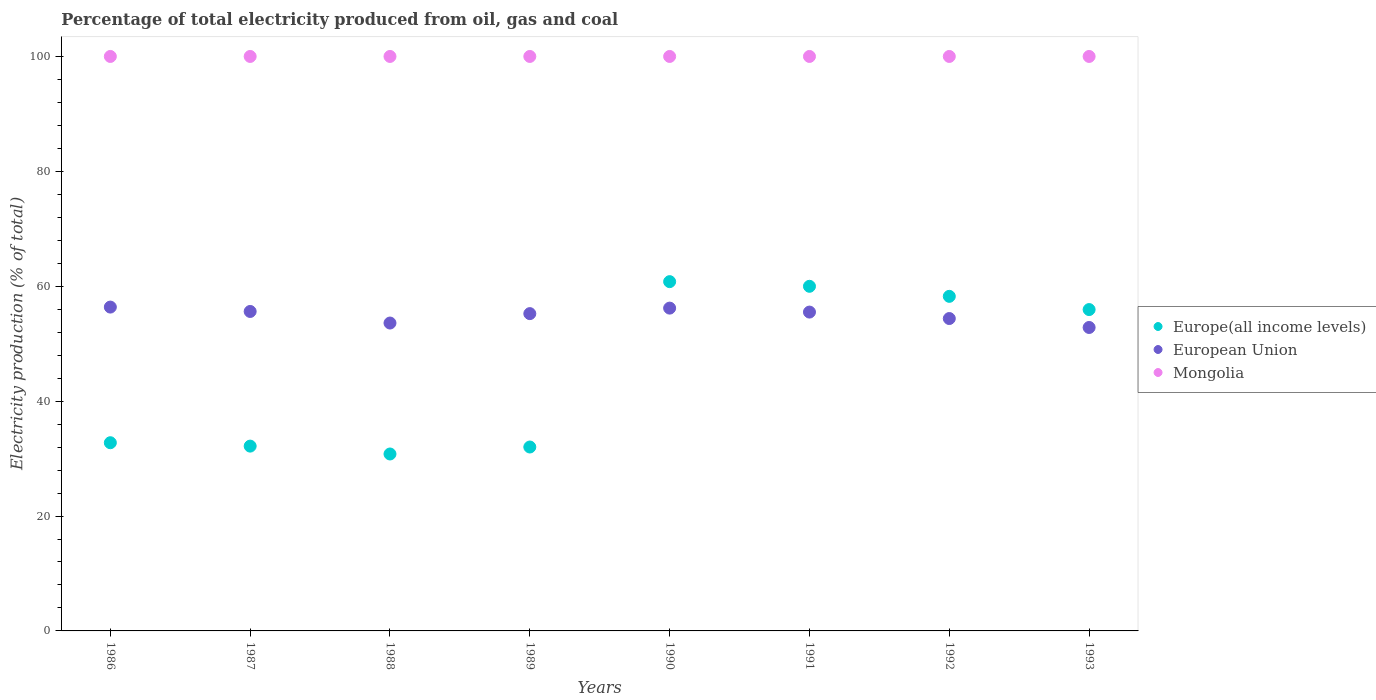What is the electricity production in in European Union in 1992?
Keep it short and to the point. 54.38. Across all years, what is the maximum electricity production in in Europe(all income levels)?
Ensure brevity in your answer.  60.8. Across all years, what is the minimum electricity production in in European Union?
Your response must be concise. 52.82. In which year was the electricity production in in Mongolia maximum?
Offer a very short reply. 1986. In which year was the electricity production in in Mongolia minimum?
Provide a succinct answer. 1986. What is the total electricity production in in Europe(all income levels) in the graph?
Your response must be concise. 362.71. What is the difference between the electricity production in in Mongolia in 1993 and the electricity production in in European Union in 1989?
Make the answer very short. 44.77. In the year 1989, what is the difference between the electricity production in in Mongolia and electricity production in in Europe(all income levels)?
Your response must be concise. 67.99. In how many years, is the electricity production in in Mongolia greater than 60 %?
Your answer should be very brief. 8. What is the ratio of the electricity production in in European Union in 1987 to that in 1992?
Give a very brief answer. 1.02. What is the difference between the highest and the second highest electricity production in in European Union?
Provide a short and direct response. 0.18. What is the difference between the highest and the lowest electricity production in in Europe(all income levels)?
Ensure brevity in your answer.  30. In how many years, is the electricity production in in Europe(all income levels) greater than the average electricity production in in Europe(all income levels) taken over all years?
Your response must be concise. 4. Is the sum of the electricity production in in Europe(all income levels) in 1988 and 1989 greater than the maximum electricity production in in Mongolia across all years?
Your answer should be very brief. No. Is it the case that in every year, the sum of the electricity production in in European Union and electricity production in in Mongolia  is greater than the electricity production in in Europe(all income levels)?
Keep it short and to the point. Yes. Does the electricity production in in Europe(all income levels) monotonically increase over the years?
Provide a succinct answer. No. Is the electricity production in in European Union strictly less than the electricity production in in Mongolia over the years?
Make the answer very short. Yes. How many dotlines are there?
Offer a very short reply. 3. What is the difference between two consecutive major ticks on the Y-axis?
Offer a terse response. 20. Are the values on the major ticks of Y-axis written in scientific E-notation?
Provide a short and direct response. No. Does the graph contain any zero values?
Give a very brief answer. No. Does the graph contain grids?
Your answer should be very brief. No. What is the title of the graph?
Your response must be concise. Percentage of total electricity produced from oil, gas and coal. Does "Sub-Saharan Africa (developing only)" appear as one of the legend labels in the graph?
Offer a very short reply. No. What is the label or title of the X-axis?
Offer a very short reply. Years. What is the label or title of the Y-axis?
Provide a succinct answer. Electricity production (% of total). What is the Electricity production (% of total) of Europe(all income levels) in 1986?
Your answer should be very brief. 32.76. What is the Electricity production (% of total) of European Union in 1986?
Offer a very short reply. 56.37. What is the Electricity production (% of total) in Europe(all income levels) in 1987?
Keep it short and to the point. 32.17. What is the Electricity production (% of total) of European Union in 1987?
Offer a terse response. 55.61. What is the Electricity production (% of total) in Mongolia in 1987?
Offer a terse response. 100. What is the Electricity production (% of total) of Europe(all income levels) in 1988?
Offer a terse response. 30.8. What is the Electricity production (% of total) in European Union in 1988?
Give a very brief answer. 53.59. What is the Electricity production (% of total) in Mongolia in 1988?
Provide a succinct answer. 100. What is the Electricity production (% of total) in Europe(all income levels) in 1989?
Offer a terse response. 32.01. What is the Electricity production (% of total) in European Union in 1989?
Your answer should be very brief. 55.23. What is the Electricity production (% of total) in Europe(all income levels) in 1990?
Ensure brevity in your answer.  60.8. What is the Electricity production (% of total) of European Union in 1990?
Your response must be concise. 56.19. What is the Electricity production (% of total) of Europe(all income levels) in 1991?
Your answer should be compact. 59.99. What is the Electricity production (% of total) of European Union in 1991?
Your response must be concise. 55.5. What is the Electricity production (% of total) in Mongolia in 1991?
Keep it short and to the point. 100. What is the Electricity production (% of total) of Europe(all income levels) in 1992?
Ensure brevity in your answer.  58.24. What is the Electricity production (% of total) in European Union in 1992?
Offer a very short reply. 54.38. What is the Electricity production (% of total) of Mongolia in 1992?
Your answer should be very brief. 100. What is the Electricity production (% of total) of Europe(all income levels) in 1993?
Make the answer very short. 55.94. What is the Electricity production (% of total) in European Union in 1993?
Your answer should be very brief. 52.82. Across all years, what is the maximum Electricity production (% of total) in Europe(all income levels)?
Give a very brief answer. 60.8. Across all years, what is the maximum Electricity production (% of total) in European Union?
Your answer should be compact. 56.37. Across all years, what is the maximum Electricity production (% of total) of Mongolia?
Provide a short and direct response. 100. Across all years, what is the minimum Electricity production (% of total) in Europe(all income levels)?
Ensure brevity in your answer.  30.8. Across all years, what is the minimum Electricity production (% of total) in European Union?
Offer a very short reply. 52.82. Across all years, what is the minimum Electricity production (% of total) of Mongolia?
Give a very brief answer. 100. What is the total Electricity production (% of total) of Europe(all income levels) in the graph?
Provide a succinct answer. 362.71. What is the total Electricity production (% of total) in European Union in the graph?
Ensure brevity in your answer.  439.7. What is the total Electricity production (% of total) of Mongolia in the graph?
Give a very brief answer. 800. What is the difference between the Electricity production (% of total) of Europe(all income levels) in 1986 and that in 1987?
Ensure brevity in your answer.  0.59. What is the difference between the Electricity production (% of total) in European Union in 1986 and that in 1987?
Your answer should be very brief. 0.76. What is the difference between the Electricity production (% of total) of Mongolia in 1986 and that in 1987?
Provide a succinct answer. 0. What is the difference between the Electricity production (% of total) of Europe(all income levels) in 1986 and that in 1988?
Your response must be concise. 1.96. What is the difference between the Electricity production (% of total) in European Union in 1986 and that in 1988?
Your response must be concise. 2.78. What is the difference between the Electricity production (% of total) of Europe(all income levels) in 1986 and that in 1989?
Give a very brief answer. 0.75. What is the difference between the Electricity production (% of total) of European Union in 1986 and that in 1989?
Provide a succinct answer. 1.14. What is the difference between the Electricity production (% of total) of Europe(all income levels) in 1986 and that in 1990?
Your answer should be very brief. -28.04. What is the difference between the Electricity production (% of total) in European Union in 1986 and that in 1990?
Provide a succinct answer. 0.18. What is the difference between the Electricity production (% of total) of Mongolia in 1986 and that in 1990?
Provide a succinct answer. 0. What is the difference between the Electricity production (% of total) of Europe(all income levels) in 1986 and that in 1991?
Provide a short and direct response. -27.23. What is the difference between the Electricity production (% of total) in European Union in 1986 and that in 1991?
Make the answer very short. 0.87. What is the difference between the Electricity production (% of total) in Europe(all income levels) in 1986 and that in 1992?
Your response must be concise. -25.48. What is the difference between the Electricity production (% of total) in European Union in 1986 and that in 1992?
Keep it short and to the point. 1.99. What is the difference between the Electricity production (% of total) in Europe(all income levels) in 1986 and that in 1993?
Your response must be concise. -23.18. What is the difference between the Electricity production (% of total) in European Union in 1986 and that in 1993?
Provide a short and direct response. 3.55. What is the difference between the Electricity production (% of total) in Mongolia in 1986 and that in 1993?
Give a very brief answer. 0. What is the difference between the Electricity production (% of total) of Europe(all income levels) in 1987 and that in 1988?
Provide a succinct answer. 1.37. What is the difference between the Electricity production (% of total) of European Union in 1987 and that in 1988?
Your response must be concise. 2.01. What is the difference between the Electricity production (% of total) of Mongolia in 1987 and that in 1988?
Your answer should be very brief. 0. What is the difference between the Electricity production (% of total) of Europe(all income levels) in 1987 and that in 1989?
Keep it short and to the point. 0.16. What is the difference between the Electricity production (% of total) of European Union in 1987 and that in 1989?
Keep it short and to the point. 0.38. What is the difference between the Electricity production (% of total) of Mongolia in 1987 and that in 1989?
Provide a short and direct response. 0. What is the difference between the Electricity production (% of total) of Europe(all income levels) in 1987 and that in 1990?
Your response must be concise. -28.63. What is the difference between the Electricity production (% of total) in European Union in 1987 and that in 1990?
Ensure brevity in your answer.  -0.58. What is the difference between the Electricity production (% of total) of Europe(all income levels) in 1987 and that in 1991?
Give a very brief answer. -27.82. What is the difference between the Electricity production (% of total) in European Union in 1987 and that in 1991?
Ensure brevity in your answer.  0.11. What is the difference between the Electricity production (% of total) of Europe(all income levels) in 1987 and that in 1992?
Keep it short and to the point. -26.07. What is the difference between the Electricity production (% of total) in European Union in 1987 and that in 1992?
Ensure brevity in your answer.  1.23. What is the difference between the Electricity production (% of total) of Europe(all income levels) in 1987 and that in 1993?
Provide a short and direct response. -23.77. What is the difference between the Electricity production (% of total) of European Union in 1987 and that in 1993?
Your response must be concise. 2.79. What is the difference between the Electricity production (% of total) of Mongolia in 1987 and that in 1993?
Your response must be concise. 0. What is the difference between the Electricity production (% of total) in Europe(all income levels) in 1988 and that in 1989?
Offer a terse response. -1.21. What is the difference between the Electricity production (% of total) of European Union in 1988 and that in 1989?
Give a very brief answer. -1.64. What is the difference between the Electricity production (% of total) in Europe(all income levels) in 1988 and that in 1990?
Offer a terse response. -30. What is the difference between the Electricity production (% of total) of European Union in 1988 and that in 1990?
Offer a terse response. -2.6. What is the difference between the Electricity production (% of total) in Europe(all income levels) in 1988 and that in 1991?
Your response must be concise. -29.19. What is the difference between the Electricity production (% of total) in European Union in 1988 and that in 1991?
Offer a terse response. -1.91. What is the difference between the Electricity production (% of total) in Mongolia in 1988 and that in 1991?
Your response must be concise. 0. What is the difference between the Electricity production (% of total) in Europe(all income levels) in 1988 and that in 1992?
Give a very brief answer. -27.44. What is the difference between the Electricity production (% of total) of European Union in 1988 and that in 1992?
Provide a succinct answer. -0.78. What is the difference between the Electricity production (% of total) of Mongolia in 1988 and that in 1992?
Ensure brevity in your answer.  0. What is the difference between the Electricity production (% of total) of Europe(all income levels) in 1988 and that in 1993?
Provide a succinct answer. -25.14. What is the difference between the Electricity production (% of total) in European Union in 1988 and that in 1993?
Keep it short and to the point. 0.77. What is the difference between the Electricity production (% of total) of Mongolia in 1988 and that in 1993?
Offer a terse response. 0. What is the difference between the Electricity production (% of total) of Europe(all income levels) in 1989 and that in 1990?
Your answer should be very brief. -28.79. What is the difference between the Electricity production (% of total) in European Union in 1989 and that in 1990?
Give a very brief answer. -0.96. What is the difference between the Electricity production (% of total) in Mongolia in 1989 and that in 1990?
Offer a terse response. 0. What is the difference between the Electricity production (% of total) in Europe(all income levels) in 1989 and that in 1991?
Your answer should be very brief. -27.98. What is the difference between the Electricity production (% of total) in European Union in 1989 and that in 1991?
Give a very brief answer. -0.27. What is the difference between the Electricity production (% of total) in Mongolia in 1989 and that in 1991?
Provide a succinct answer. 0. What is the difference between the Electricity production (% of total) in Europe(all income levels) in 1989 and that in 1992?
Keep it short and to the point. -26.23. What is the difference between the Electricity production (% of total) in European Union in 1989 and that in 1992?
Your answer should be compact. 0.86. What is the difference between the Electricity production (% of total) of Europe(all income levels) in 1989 and that in 1993?
Offer a very short reply. -23.93. What is the difference between the Electricity production (% of total) of European Union in 1989 and that in 1993?
Offer a terse response. 2.41. What is the difference between the Electricity production (% of total) in Mongolia in 1989 and that in 1993?
Offer a very short reply. 0. What is the difference between the Electricity production (% of total) in Europe(all income levels) in 1990 and that in 1991?
Your response must be concise. 0.81. What is the difference between the Electricity production (% of total) of European Union in 1990 and that in 1991?
Your response must be concise. 0.69. What is the difference between the Electricity production (% of total) of Europe(all income levels) in 1990 and that in 1992?
Provide a succinct answer. 2.56. What is the difference between the Electricity production (% of total) of European Union in 1990 and that in 1992?
Offer a very short reply. 1.81. What is the difference between the Electricity production (% of total) of Europe(all income levels) in 1990 and that in 1993?
Your answer should be very brief. 4.86. What is the difference between the Electricity production (% of total) of European Union in 1990 and that in 1993?
Provide a short and direct response. 3.37. What is the difference between the Electricity production (% of total) in Europe(all income levels) in 1991 and that in 1992?
Offer a terse response. 1.75. What is the difference between the Electricity production (% of total) in European Union in 1991 and that in 1992?
Ensure brevity in your answer.  1.12. What is the difference between the Electricity production (% of total) in Mongolia in 1991 and that in 1992?
Provide a succinct answer. 0. What is the difference between the Electricity production (% of total) of Europe(all income levels) in 1991 and that in 1993?
Make the answer very short. 4.05. What is the difference between the Electricity production (% of total) in European Union in 1991 and that in 1993?
Give a very brief answer. 2.68. What is the difference between the Electricity production (% of total) in Mongolia in 1991 and that in 1993?
Give a very brief answer. 0. What is the difference between the Electricity production (% of total) in Europe(all income levels) in 1992 and that in 1993?
Your answer should be very brief. 2.3. What is the difference between the Electricity production (% of total) of European Union in 1992 and that in 1993?
Your answer should be very brief. 1.56. What is the difference between the Electricity production (% of total) in Europe(all income levels) in 1986 and the Electricity production (% of total) in European Union in 1987?
Provide a short and direct response. -22.85. What is the difference between the Electricity production (% of total) of Europe(all income levels) in 1986 and the Electricity production (% of total) of Mongolia in 1987?
Provide a succinct answer. -67.24. What is the difference between the Electricity production (% of total) of European Union in 1986 and the Electricity production (% of total) of Mongolia in 1987?
Your answer should be very brief. -43.63. What is the difference between the Electricity production (% of total) of Europe(all income levels) in 1986 and the Electricity production (% of total) of European Union in 1988?
Make the answer very short. -20.83. What is the difference between the Electricity production (% of total) in Europe(all income levels) in 1986 and the Electricity production (% of total) in Mongolia in 1988?
Ensure brevity in your answer.  -67.24. What is the difference between the Electricity production (% of total) in European Union in 1986 and the Electricity production (% of total) in Mongolia in 1988?
Offer a very short reply. -43.63. What is the difference between the Electricity production (% of total) of Europe(all income levels) in 1986 and the Electricity production (% of total) of European Union in 1989?
Offer a very short reply. -22.47. What is the difference between the Electricity production (% of total) of Europe(all income levels) in 1986 and the Electricity production (% of total) of Mongolia in 1989?
Offer a terse response. -67.24. What is the difference between the Electricity production (% of total) of European Union in 1986 and the Electricity production (% of total) of Mongolia in 1989?
Provide a short and direct response. -43.63. What is the difference between the Electricity production (% of total) of Europe(all income levels) in 1986 and the Electricity production (% of total) of European Union in 1990?
Your response must be concise. -23.43. What is the difference between the Electricity production (% of total) in Europe(all income levels) in 1986 and the Electricity production (% of total) in Mongolia in 1990?
Provide a short and direct response. -67.24. What is the difference between the Electricity production (% of total) of European Union in 1986 and the Electricity production (% of total) of Mongolia in 1990?
Your answer should be compact. -43.63. What is the difference between the Electricity production (% of total) in Europe(all income levels) in 1986 and the Electricity production (% of total) in European Union in 1991?
Keep it short and to the point. -22.74. What is the difference between the Electricity production (% of total) in Europe(all income levels) in 1986 and the Electricity production (% of total) in Mongolia in 1991?
Offer a terse response. -67.24. What is the difference between the Electricity production (% of total) in European Union in 1986 and the Electricity production (% of total) in Mongolia in 1991?
Your answer should be compact. -43.63. What is the difference between the Electricity production (% of total) in Europe(all income levels) in 1986 and the Electricity production (% of total) in European Union in 1992?
Provide a short and direct response. -21.62. What is the difference between the Electricity production (% of total) of Europe(all income levels) in 1986 and the Electricity production (% of total) of Mongolia in 1992?
Offer a terse response. -67.24. What is the difference between the Electricity production (% of total) in European Union in 1986 and the Electricity production (% of total) in Mongolia in 1992?
Your answer should be compact. -43.63. What is the difference between the Electricity production (% of total) of Europe(all income levels) in 1986 and the Electricity production (% of total) of European Union in 1993?
Your response must be concise. -20.06. What is the difference between the Electricity production (% of total) of Europe(all income levels) in 1986 and the Electricity production (% of total) of Mongolia in 1993?
Ensure brevity in your answer.  -67.24. What is the difference between the Electricity production (% of total) of European Union in 1986 and the Electricity production (% of total) of Mongolia in 1993?
Give a very brief answer. -43.63. What is the difference between the Electricity production (% of total) in Europe(all income levels) in 1987 and the Electricity production (% of total) in European Union in 1988?
Offer a very short reply. -21.42. What is the difference between the Electricity production (% of total) in Europe(all income levels) in 1987 and the Electricity production (% of total) in Mongolia in 1988?
Offer a terse response. -67.83. What is the difference between the Electricity production (% of total) of European Union in 1987 and the Electricity production (% of total) of Mongolia in 1988?
Ensure brevity in your answer.  -44.39. What is the difference between the Electricity production (% of total) in Europe(all income levels) in 1987 and the Electricity production (% of total) in European Union in 1989?
Your response must be concise. -23.06. What is the difference between the Electricity production (% of total) in Europe(all income levels) in 1987 and the Electricity production (% of total) in Mongolia in 1989?
Ensure brevity in your answer.  -67.83. What is the difference between the Electricity production (% of total) in European Union in 1987 and the Electricity production (% of total) in Mongolia in 1989?
Ensure brevity in your answer.  -44.39. What is the difference between the Electricity production (% of total) in Europe(all income levels) in 1987 and the Electricity production (% of total) in European Union in 1990?
Offer a terse response. -24.02. What is the difference between the Electricity production (% of total) of Europe(all income levels) in 1987 and the Electricity production (% of total) of Mongolia in 1990?
Keep it short and to the point. -67.83. What is the difference between the Electricity production (% of total) in European Union in 1987 and the Electricity production (% of total) in Mongolia in 1990?
Offer a very short reply. -44.39. What is the difference between the Electricity production (% of total) of Europe(all income levels) in 1987 and the Electricity production (% of total) of European Union in 1991?
Your answer should be very brief. -23.33. What is the difference between the Electricity production (% of total) of Europe(all income levels) in 1987 and the Electricity production (% of total) of Mongolia in 1991?
Ensure brevity in your answer.  -67.83. What is the difference between the Electricity production (% of total) in European Union in 1987 and the Electricity production (% of total) in Mongolia in 1991?
Provide a short and direct response. -44.39. What is the difference between the Electricity production (% of total) of Europe(all income levels) in 1987 and the Electricity production (% of total) of European Union in 1992?
Offer a very short reply. -22.21. What is the difference between the Electricity production (% of total) of Europe(all income levels) in 1987 and the Electricity production (% of total) of Mongolia in 1992?
Your response must be concise. -67.83. What is the difference between the Electricity production (% of total) in European Union in 1987 and the Electricity production (% of total) in Mongolia in 1992?
Your response must be concise. -44.39. What is the difference between the Electricity production (% of total) of Europe(all income levels) in 1987 and the Electricity production (% of total) of European Union in 1993?
Your answer should be compact. -20.65. What is the difference between the Electricity production (% of total) of Europe(all income levels) in 1987 and the Electricity production (% of total) of Mongolia in 1993?
Offer a terse response. -67.83. What is the difference between the Electricity production (% of total) of European Union in 1987 and the Electricity production (% of total) of Mongolia in 1993?
Your response must be concise. -44.39. What is the difference between the Electricity production (% of total) in Europe(all income levels) in 1988 and the Electricity production (% of total) in European Union in 1989?
Your answer should be compact. -24.43. What is the difference between the Electricity production (% of total) in Europe(all income levels) in 1988 and the Electricity production (% of total) in Mongolia in 1989?
Provide a short and direct response. -69.2. What is the difference between the Electricity production (% of total) in European Union in 1988 and the Electricity production (% of total) in Mongolia in 1989?
Ensure brevity in your answer.  -46.41. What is the difference between the Electricity production (% of total) in Europe(all income levels) in 1988 and the Electricity production (% of total) in European Union in 1990?
Offer a very short reply. -25.39. What is the difference between the Electricity production (% of total) in Europe(all income levels) in 1988 and the Electricity production (% of total) in Mongolia in 1990?
Provide a succinct answer. -69.2. What is the difference between the Electricity production (% of total) in European Union in 1988 and the Electricity production (% of total) in Mongolia in 1990?
Offer a terse response. -46.41. What is the difference between the Electricity production (% of total) in Europe(all income levels) in 1988 and the Electricity production (% of total) in European Union in 1991?
Ensure brevity in your answer.  -24.7. What is the difference between the Electricity production (% of total) in Europe(all income levels) in 1988 and the Electricity production (% of total) in Mongolia in 1991?
Provide a short and direct response. -69.2. What is the difference between the Electricity production (% of total) in European Union in 1988 and the Electricity production (% of total) in Mongolia in 1991?
Give a very brief answer. -46.41. What is the difference between the Electricity production (% of total) of Europe(all income levels) in 1988 and the Electricity production (% of total) of European Union in 1992?
Provide a succinct answer. -23.58. What is the difference between the Electricity production (% of total) of Europe(all income levels) in 1988 and the Electricity production (% of total) of Mongolia in 1992?
Give a very brief answer. -69.2. What is the difference between the Electricity production (% of total) in European Union in 1988 and the Electricity production (% of total) in Mongolia in 1992?
Offer a terse response. -46.41. What is the difference between the Electricity production (% of total) of Europe(all income levels) in 1988 and the Electricity production (% of total) of European Union in 1993?
Keep it short and to the point. -22.02. What is the difference between the Electricity production (% of total) in Europe(all income levels) in 1988 and the Electricity production (% of total) in Mongolia in 1993?
Offer a terse response. -69.2. What is the difference between the Electricity production (% of total) of European Union in 1988 and the Electricity production (% of total) of Mongolia in 1993?
Provide a succinct answer. -46.41. What is the difference between the Electricity production (% of total) in Europe(all income levels) in 1989 and the Electricity production (% of total) in European Union in 1990?
Keep it short and to the point. -24.18. What is the difference between the Electricity production (% of total) in Europe(all income levels) in 1989 and the Electricity production (% of total) in Mongolia in 1990?
Your answer should be compact. -67.99. What is the difference between the Electricity production (% of total) of European Union in 1989 and the Electricity production (% of total) of Mongolia in 1990?
Your response must be concise. -44.77. What is the difference between the Electricity production (% of total) in Europe(all income levels) in 1989 and the Electricity production (% of total) in European Union in 1991?
Your answer should be compact. -23.49. What is the difference between the Electricity production (% of total) in Europe(all income levels) in 1989 and the Electricity production (% of total) in Mongolia in 1991?
Give a very brief answer. -67.99. What is the difference between the Electricity production (% of total) of European Union in 1989 and the Electricity production (% of total) of Mongolia in 1991?
Make the answer very short. -44.77. What is the difference between the Electricity production (% of total) in Europe(all income levels) in 1989 and the Electricity production (% of total) in European Union in 1992?
Your response must be concise. -22.36. What is the difference between the Electricity production (% of total) in Europe(all income levels) in 1989 and the Electricity production (% of total) in Mongolia in 1992?
Provide a succinct answer. -67.99. What is the difference between the Electricity production (% of total) of European Union in 1989 and the Electricity production (% of total) of Mongolia in 1992?
Ensure brevity in your answer.  -44.77. What is the difference between the Electricity production (% of total) of Europe(all income levels) in 1989 and the Electricity production (% of total) of European Union in 1993?
Offer a very short reply. -20.81. What is the difference between the Electricity production (% of total) of Europe(all income levels) in 1989 and the Electricity production (% of total) of Mongolia in 1993?
Ensure brevity in your answer.  -67.99. What is the difference between the Electricity production (% of total) of European Union in 1989 and the Electricity production (% of total) of Mongolia in 1993?
Offer a very short reply. -44.77. What is the difference between the Electricity production (% of total) in Europe(all income levels) in 1990 and the Electricity production (% of total) in European Union in 1991?
Provide a short and direct response. 5.3. What is the difference between the Electricity production (% of total) in Europe(all income levels) in 1990 and the Electricity production (% of total) in Mongolia in 1991?
Make the answer very short. -39.2. What is the difference between the Electricity production (% of total) in European Union in 1990 and the Electricity production (% of total) in Mongolia in 1991?
Keep it short and to the point. -43.81. What is the difference between the Electricity production (% of total) in Europe(all income levels) in 1990 and the Electricity production (% of total) in European Union in 1992?
Offer a terse response. 6.42. What is the difference between the Electricity production (% of total) in Europe(all income levels) in 1990 and the Electricity production (% of total) in Mongolia in 1992?
Make the answer very short. -39.2. What is the difference between the Electricity production (% of total) of European Union in 1990 and the Electricity production (% of total) of Mongolia in 1992?
Provide a short and direct response. -43.81. What is the difference between the Electricity production (% of total) of Europe(all income levels) in 1990 and the Electricity production (% of total) of European Union in 1993?
Give a very brief answer. 7.98. What is the difference between the Electricity production (% of total) of Europe(all income levels) in 1990 and the Electricity production (% of total) of Mongolia in 1993?
Offer a terse response. -39.2. What is the difference between the Electricity production (% of total) of European Union in 1990 and the Electricity production (% of total) of Mongolia in 1993?
Offer a terse response. -43.81. What is the difference between the Electricity production (% of total) of Europe(all income levels) in 1991 and the Electricity production (% of total) of European Union in 1992?
Offer a terse response. 5.61. What is the difference between the Electricity production (% of total) of Europe(all income levels) in 1991 and the Electricity production (% of total) of Mongolia in 1992?
Give a very brief answer. -40.01. What is the difference between the Electricity production (% of total) of European Union in 1991 and the Electricity production (% of total) of Mongolia in 1992?
Your answer should be very brief. -44.5. What is the difference between the Electricity production (% of total) in Europe(all income levels) in 1991 and the Electricity production (% of total) in European Union in 1993?
Your response must be concise. 7.17. What is the difference between the Electricity production (% of total) of Europe(all income levels) in 1991 and the Electricity production (% of total) of Mongolia in 1993?
Your response must be concise. -40.01. What is the difference between the Electricity production (% of total) in European Union in 1991 and the Electricity production (% of total) in Mongolia in 1993?
Your response must be concise. -44.5. What is the difference between the Electricity production (% of total) in Europe(all income levels) in 1992 and the Electricity production (% of total) in European Union in 1993?
Offer a terse response. 5.42. What is the difference between the Electricity production (% of total) in Europe(all income levels) in 1992 and the Electricity production (% of total) in Mongolia in 1993?
Your answer should be very brief. -41.76. What is the difference between the Electricity production (% of total) in European Union in 1992 and the Electricity production (% of total) in Mongolia in 1993?
Your response must be concise. -45.62. What is the average Electricity production (% of total) in Europe(all income levels) per year?
Provide a short and direct response. 45.34. What is the average Electricity production (% of total) in European Union per year?
Keep it short and to the point. 54.96. What is the average Electricity production (% of total) of Mongolia per year?
Offer a very short reply. 100. In the year 1986, what is the difference between the Electricity production (% of total) of Europe(all income levels) and Electricity production (% of total) of European Union?
Offer a very short reply. -23.61. In the year 1986, what is the difference between the Electricity production (% of total) in Europe(all income levels) and Electricity production (% of total) in Mongolia?
Offer a very short reply. -67.24. In the year 1986, what is the difference between the Electricity production (% of total) of European Union and Electricity production (% of total) of Mongolia?
Keep it short and to the point. -43.63. In the year 1987, what is the difference between the Electricity production (% of total) of Europe(all income levels) and Electricity production (% of total) of European Union?
Provide a short and direct response. -23.44. In the year 1987, what is the difference between the Electricity production (% of total) in Europe(all income levels) and Electricity production (% of total) in Mongolia?
Your answer should be very brief. -67.83. In the year 1987, what is the difference between the Electricity production (% of total) in European Union and Electricity production (% of total) in Mongolia?
Ensure brevity in your answer.  -44.39. In the year 1988, what is the difference between the Electricity production (% of total) in Europe(all income levels) and Electricity production (% of total) in European Union?
Your answer should be very brief. -22.79. In the year 1988, what is the difference between the Electricity production (% of total) of Europe(all income levels) and Electricity production (% of total) of Mongolia?
Give a very brief answer. -69.2. In the year 1988, what is the difference between the Electricity production (% of total) of European Union and Electricity production (% of total) of Mongolia?
Give a very brief answer. -46.41. In the year 1989, what is the difference between the Electricity production (% of total) in Europe(all income levels) and Electricity production (% of total) in European Union?
Your answer should be compact. -23.22. In the year 1989, what is the difference between the Electricity production (% of total) in Europe(all income levels) and Electricity production (% of total) in Mongolia?
Your response must be concise. -67.99. In the year 1989, what is the difference between the Electricity production (% of total) of European Union and Electricity production (% of total) of Mongolia?
Your response must be concise. -44.77. In the year 1990, what is the difference between the Electricity production (% of total) of Europe(all income levels) and Electricity production (% of total) of European Union?
Give a very brief answer. 4.61. In the year 1990, what is the difference between the Electricity production (% of total) of Europe(all income levels) and Electricity production (% of total) of Mongolia?
Your response must be concise. -39.2. In the year 1990, what is the difference between the Electricity production (% of total) of European Union and Electricity production (% of total) of Mongolia?
Provide a short and direct response. -43.81. In the year 1991, what is the difference between the Electricity production (% of total) of Europe(all income levels) and Electricity production (% of total) of European Union?
Your answer should be very brief. 4.49. In the year 1991, what is the difference between the Electricity production (% of total) of Europe(all income levels) and Electricity production (% of total) of Mongolia?
Make the answer very short. -40.01. In the year 1991, what is the difference between the Electricity production (% of total) in European Union and Electricity production (% of total) in Mongolia?
Your answer should be compact. -44.5. In the year 1992, what is the difference between the Electricity production (% of total) in Europe(all income levels) and Electricity production (% of total) in European Union?
Ensure brevity in your answer.  3.86. In the year 1992, what is the difference between the Electricity production (% of total) of Europe(all income levels) and Electricity production (% of total) of Mongolia?
Provide a short and direct response. -41.76. In the year 1992, what is the difference between the Electricity production (% of total) in European Union and Electricity production (% of total) in Mongolia?
Your response must be concise. -45.62. In the year 1993, what is the difference between the Electricity production (% of total) of Europe(all income levels) and Electricity production (% of total) of European Union?
Offer a terse response. 3.12. In the year 1993, what is the difference between the Electricity production (% of total) of Europe(all income levels) and Electricity production (% of total) of Mongolia?
Your answer should be compact. -44.06. In the year 1993, what is the difference between the Electricity production (% of total) in European Union and Electricity production (% of total) in Mongolia?
Provide a short and direct response. -47.18. What is the ratio of the Electricity production (% of total) in Europe(all income levels) in 1986 to that in 1987?
Make the answer very short. 1.02. What is the ratio of the Electricity production (% of total) in European Union in 1986 to that in 1987?
Offer a very short reply. 1.01. What is the ratio of the Electricity production (% of total) of Mongolia in 1986 to that in 1987?
Provide a short and direct response. 1. What is the ratio of the Electricity production (% of total) in Europe(all income levels) in 1986 to that in 1988?
Offer a very short reply. 1.06. What is the ratio of the Electricity production (% of total) in European Union in 1986 to that in 1988?
Make the answer very short. 1.05. What is the ratio of the Electricity production (% of total) of Mongolia in 1986 to that in 1988?
Offer a terse response. 1. What is the ratio of the Electricity production (% of total) of Europe(all income levels) in 1986 to that in 1989?
Your answer should be very brief. 1.02. What is the ratio of the Electricity production (% of total) in European Union in 1986 to that in 1989?
Your response must be concise. 1.02. What is the ratio of the Electricity production (% of total) of Mongolia in 1986 to that in 1989?
Provide a succinct answer. 1. What is the ratio of the Electricity production (% of total) in Europe(all income levels) in 1986 to that in 1990?
Make the answer very short. 0.54. What is the ratio of the Electricity production (% of total) of Europe(all income levels) in 1986 to that in 1991?
Provide a short and direct response. 0.55. What is the ratio of the Electricity production (% of total) in European Union in 1986 to that in 1991?
Make the answer very short. 1.02. What is the ratio of the Electricity production (% of total) in Mongolia in 1986 to that in 1991?
Ensure brevity in your answer.  1. What is the ratio of the Electricity production (% of total) of Europe(all income levels) in 1986 to that in 1992?
Give a very brief answer. 0.56. What is the ratio of the Electricity production (% of total) of European Union in 1986 to that in 1992?
Provide a succinct answer. 1.04. What is the ratio of the Electricity production (% of total) in Mongolia in 1986 to that in 1992?
Ensure brevity in your answer.  1. What is the ratio of the Electricity production (% of total) in Europe(all income levels) in 1986 to that in 1993?
Your answer should be compact. 0.59. What is the ratio of the Electricity production (% of total) of European Union in 1986 to that in 1993?
Ensure brevity in your answer.  1.07. What is the ratio of the Electricity production (% of total) of Mongolia in 1986 to that in 1993?
Give a very brief answer. 1. What is the ratio of the Electricity production (% of total) of Europe(all income levels) in 1987 to that in 1988?
Keep it short and to the point. 1.04. What is the ratio of the Electricity production (% of total) of European Union in 1987 to that in 1988?
Your answer should be compact. 1.04. What is the ratio of the Electricity production (% of total) in Mongolia in 1987 to that in 1988?
Make the answer very short. 1. What is the ratio of the Electricity production (% of total) in European Union in 1987 to that in 1989?
Your answer should be very brief. 1.01. What is the ratio of the Electricity production (% of total) of Mongolia in 1987 to that in 1989?
Keep it short and to the point. 1. What is the ratio of the Electricity production (% of total) of Europe(all income levels) in 1987 to that in 1990?
Offer a very short reply. 0.53. What is the ratio of the Electricity production (% of total) in Mongolia in 1987 to that in 1990?
Your response must be concise. 1. What is the ratio of the Electricity production (% of total) of Europe(all income levels) in 1987 to that in 1991?
Provide a succinct answer. 0.54. What is the ratio of the Electricity production (% of total) of European Union in 1987 to that in 1991?
Your answer should be very brief. 1. What is the ratio of the Electricity production (% of total) of Mongolia in 1987 to that in 1991?
Your answer should be very brief. 1. What is the ratio of the Electricity production (% of total) of Europe(all income levels) in 1987 to that in 1992?
Provide a short and direct response. 0.55. What is the ratio of the Electricity production (% of total) in European Union in 1987 to that in 1992?
Ensure brevity in your answer.  1.02. What is the ratio of the Electricity production (% of total) in Europe(all income levels) in 1987 to that in 1993?
Provide a succinct answer. 0.58. What is the ratio of the Electricity production (% of total) in European Union in 1987 to that in 1993?
Keep it short and to the point. 1.05. What is the ratio of the Electricity production (% of total) of Mongolia in 1987 to that in 1993?
Offer a very short reply. 1. What is the ratio of the Electricity production (% of total) in Europe(all income levels) in 1988 to that in 1989?
Ensure brevity in your answer.  0.96. What is the ratio of the Electricity production (% of total) in European Union in 1988 to that in 1989?
Offer a terse response. 0.97. What is the ratio of the Electricity production (% of total) of Europe(all income levels) in 1988 to that in 1990?
Offer a very short reply. 0.51. What is the ratio of the Electricity production (% of total) of European Union in 1988 to that in 1990?
Provide a succinct answer. 0.95. What is the ratio of the Electricity production (% of total) in Europe(all income levels) in 1988 to that in 1991?
Give a very brief answer. 0.51. What is the ratio of the Electricity production (% of total) in European Union in 1988 to that in 1991?
Ensure brevity in your answer.  0.97. What is the ratio of the Electricity production (% of total) of Europe(all income levels) in 1988 to that in 1992?
Provide a succinct answer. 0.53. What is the ratio of the Electricity production (% of total) of European Union in 1988 to that in 1992?
Your answer should be compact. 0.99. What is the ratio of the Electricity production (% of total) in Europe(all income levels) in 1988 to that in 1993?
Keep it short and to the point. 0.55. What is the ratio of the Electricity production (% of total) of European Union in 1988 to that in 1993?
Your answer should be very brief. 1.01. What is the ratio of the Electricity production (% of total) in Europe(all income levels) in 1989 to that in 1990?
Provide a succinct answer. 0.53. What is the ratio of the Electricity production (% of total) of European Union in 1989 to that in 1990?
Offer a very short reply. 0.98. What is the ratio of the Electricity production (% of total) in Europe(all income levels) in 1989 to that in 1991?
Provide a succinct answer. 0.53. What is the ratio of the Electricity production (% of total) in European Union in 1989 to that in 1991?
Offer a very short reply. 1. What is the ratio of the Electricity production (% of total) of Europe(all income levels) in 1989 to that in 1992?
Make the answer very short. 0.55. What is the ratio of the Electricity production (% of total) in European Union in 1989 to that in 1992?
Keep it short and to the point. 1.02. What is the ratio of the Electricity production (% of total) of Mongolia in 1989 to that in 1992?
Provide a succinct answer. 1. What is the ratio of the Electricity production (% of total) in Europe(all income levels) in 1989 to that in 1993?
Offer a very short reply. 0.57. What is the ratio of the Electricity production (% of total) in European Union in 1989 to that in 1993?
Offer a terse response. 1.05. What is the ratio of the Electricity production (% of total) in Mongolia in 1989 to that in 1993?
Your answer should be very brief. 1. What is the ratio of the Electricity production (% of total) in Europe(all income levels) in 1990 to that in 1991?
Offer a terse response. 1.01. What is the ratio of the Electricity production (% of total) in European Union in 1990 to that in 1991?
Your answer should be very brief. 1.01. What is the ratio of the Electricity production (% of total) in Mongolia in 1990 to that in 1991?
Provide a short and direct response. 1. What is the ratio of the Electricity production (% of total) in Europe(all income levels) in 1990 to that in 1992?
Your answer should be compact. 1.04. What is the ratio of the Electricity production (% of total) of European Union in 1990 to that in 1992?
Make the answer very short. 1.03. What is the ratio of the Electricity production (% of total) of Mongolia in 1990 to that in 1992?
Your answer should be compact. 1. What is the ratio of the Electricity production (% of total) in Europe(all income levels) in 1990 to that in 1993?
Your response must be concise. 1.09. What is the ratio of the Electricity production (% of total) of European Union in 1990 to that in 1993?
Keep it short and to the point. 1.06. What is the ratio of the Electricity production (% of total) in Mongolia in 1990 to that in 1993?
Ensure brevity in your answer.  1. What is the ratio of the Electricity production (% of total) in Europe(all income levels) in 1991 to that in 1992?
Ensure brevity in your answer.  1.03. What is the ratio of the Electricity production (% of total) in European Union in 1991 to that in 1992?
Your answer should be very brief. 1.02. What is the ratio of the Electricity production (% of total) of Europe(all income levels) in 1991 to that in 1993?
Your answer should be compact. 1.07. What is the ratio of the Electricity production (% of total) in European Union in 1991 to that in 1993?
Offer a terse response. 1.05. What is the ratio of the Electricity production (% of total) of Europe(all income levels) in 1992 to that in 1993?
Your answer should be compact. 1.04. What is the ratio of the Electricity production (% of total) in European Union in 1992 to that in 1993?
Your answer should be compact. 1.03. What is the difference between the highest and the second highest Electricity production (% of total) of Europe(all income levels)?
Your response must be concise. 0.81. What is the difference between the highest and the second highest Electricity production (% of total) of European Union?
Ensure brevity in your answer.  0.18. What is the difference between the highest and the second highest Electricity production (% of total) of Mongolia?
Provide a short and direct response. 0. What is the difference between the highest and the lowest Electricity production (% of total) of Europe(all income levels)?
Provide a succinct answer. 30. What is the difference between the highest and the lowest Electricity production (% of total) in European Union?
Make the answer very short. 3.55. What is the difference between the highest and the lowest Electricity production (% of total) in Mongolia?
Your answer should be very brief. 0. 